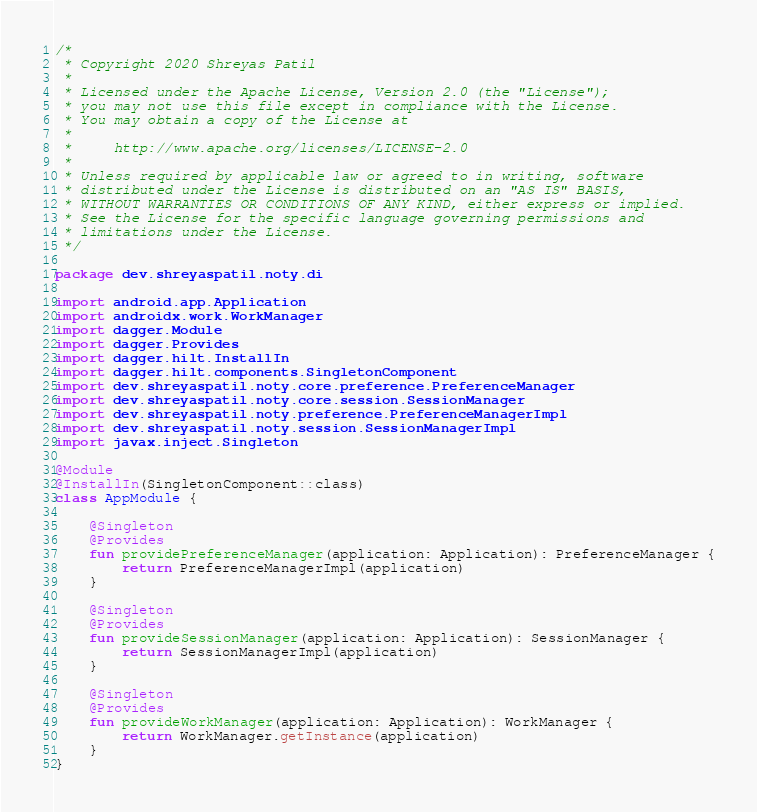Convert code to text. <code><loc_0><loc_0><loc_500><loc_500><_Kotlin_>/*
 * Copyright 2020 Shreyas Patil
 *
 * Licensed under the Apache License, Version 2.0 (the "License");
 * you may not use this file except in compliance with the License.
 * You may obtain a copy of the License at
 *
 *     http://www.apache.org/licenses/LICENSE-2.0
 *
 * Unless required by applicable law or agreed to in writing, software
 * distributed under the License is distributed on an "AS IS" BASIS,
 * WITHOUT WARRANTIES OR CONDITIONS OF ANY KIND, either express or implied.
 * See the License for the specific language governing permissions and
 * limitations under the License.
 */

package dev.shreyaspatil.noty.di

import android.app.Application
import androidx.work.WorkManager
import dagger.Module
import dagger.Provides
import dagger.hilt.InstallIn
import dagger.hilt.components.SingletonComponent
import dev.shreyaspatil.noty.core.preference.PreferenceManager
import dev.shreyaspatil.noty.core.session.SessionManager
import dev.shreyaspatil.noty.preference.PreferenceManagerImpl
import dev.shreyaspatil.noty.session.SessionManagerImpl
import javax.inject.Singleton

@Module
@InstallIn(SingletonComponent::class)
class AppModule {

    @Singleton
    @Provides
    fun providePreferenceManager(application: Application): PreferenceManager {
        return PreferenceManagerImpl(application)
    }

    @Singleton
    @Provides
    fun provideSessionManager(application: Application): SessionManager {
        return SessionManagerImpl(application)
    }

    @Singleton
    @Provides
    fun provideWorkManager(application: Application): WorkManager {
        return WorkManager.getInstance(application)
    }
}
</code> 